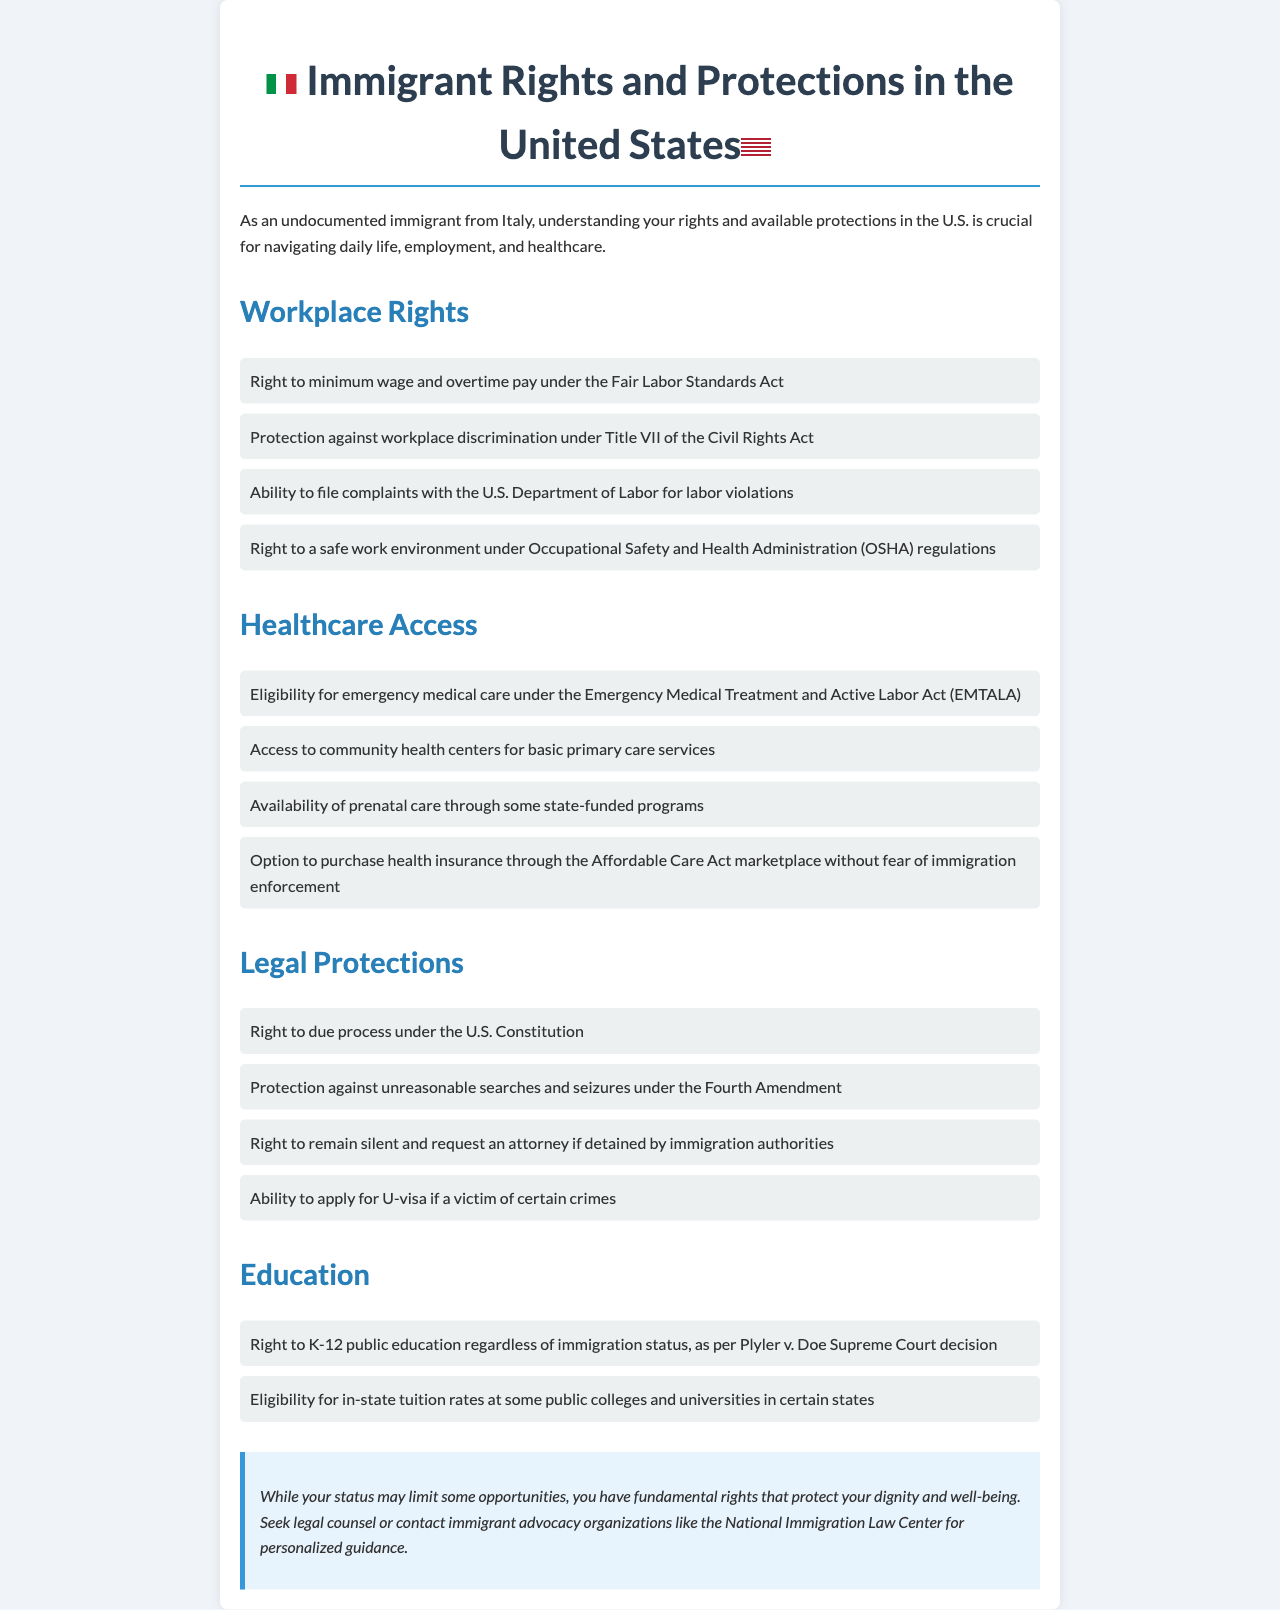what is the title of the document? The title is presented prominently at the top of the document, which is "Immigrant Rights and Protections in the United States."
Answer: Immigrant Rights and Protections in the United States how many workplace rights are listed? The document lists four specific workplace rights under the Workplace Rights section.
Answer: Four what does OSHA stand for? OSHA is an acronym mentioned in the document referring to the Occupational Safety and Health Administration.
Answer: Occupational Safety and Health Administration which act provides eligibility for emergency medical care? The document states that eligibility for emergency medical care is provided under the Emergency Medical Treatment and Active Labor Act.
Answer: Emergency Medical Treatment and Active Labor Act what is the right to K-12 education regardless of immigration status based on? The right to K-12 public education is based on the Plyler v. Doe Supreme Court decision.
Answer: Plyler v. Doe what is the maximum number of rights listed under Legal Protections? The document lists four specific legal protections in the Legal Protections section.
Answer: Four which organization can provide personalized guidance? The document suggests seeking assistance from immigrant advocacy organizations, specifically mentioning the National Immigration Law Center for guidance.
Answer: National Immigration Law Center name one right related to workplace discrimination. The document identifies protection against workplace discrimination under Title VII of the Civil Rights Act as a specific right related to workplace discrimination.
Answer: Title VII of the Civil Rights Act 